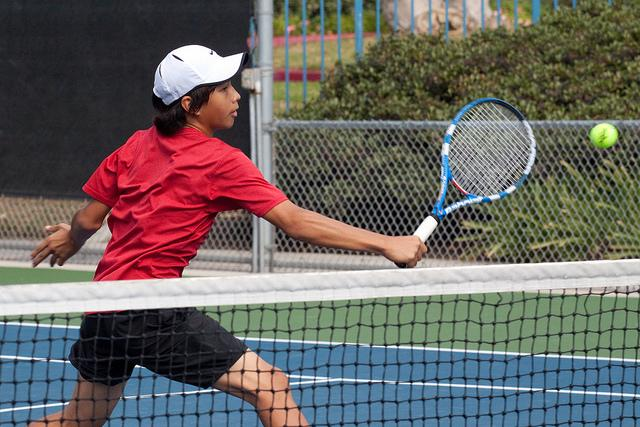Why is the boy reaching for the ball? hit 